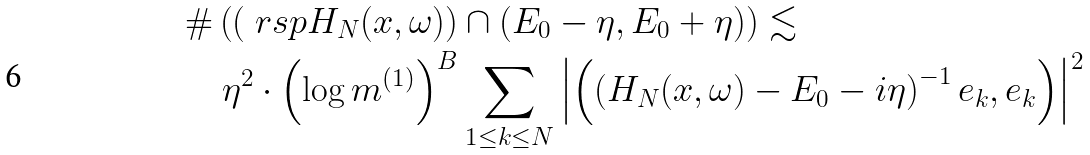<formula> <loc_0><loc_0><loc_500><loc_500>& \# \left ( \left ( \ r s p H _ { N } ( x , \omega ) \right ) \cap \left ( E _ { 0 } - \eta , E _ { 0 } + \eta \right ) \right ) \lesssim \\ & \quad \eta ^ { 2 } \cdot \left ( \log m ^ { ( 1 ) } \right ) ^ { B } \sum _ { 1 \leq k \leq N } \left | \left ( \left ( H _ { N } ( x , \omega ) - E _ { 0 } - i \eta \right ) ^ { - 1 } e _ { k } , e _ { k } \right ) \right | ^ { 2 }</formula> 